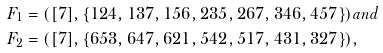<formula> <loc_0><loc_0><loc_500><loc_500>F _ { 1 } & = ( [ 7 ] , \{ 1 2 4 , 1 3 7 , 1 5 6 , 2 3 5 , 2 6 7 , 3 4 6 , 4 5 7 \} ) a n d \\ F _ { 2 } & = ( [ 7 ] , \{ 6 5 3 , 6 4 7 , 6 2 1 , 5 4 2 , 5 1 7 , 4 3 1 , 3 2 7 \} ) ,</formula> 